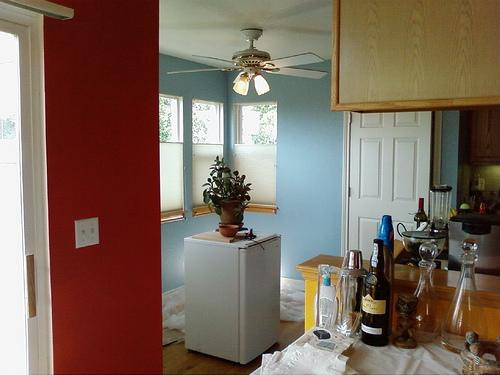What is the plant sitting on? fridge 